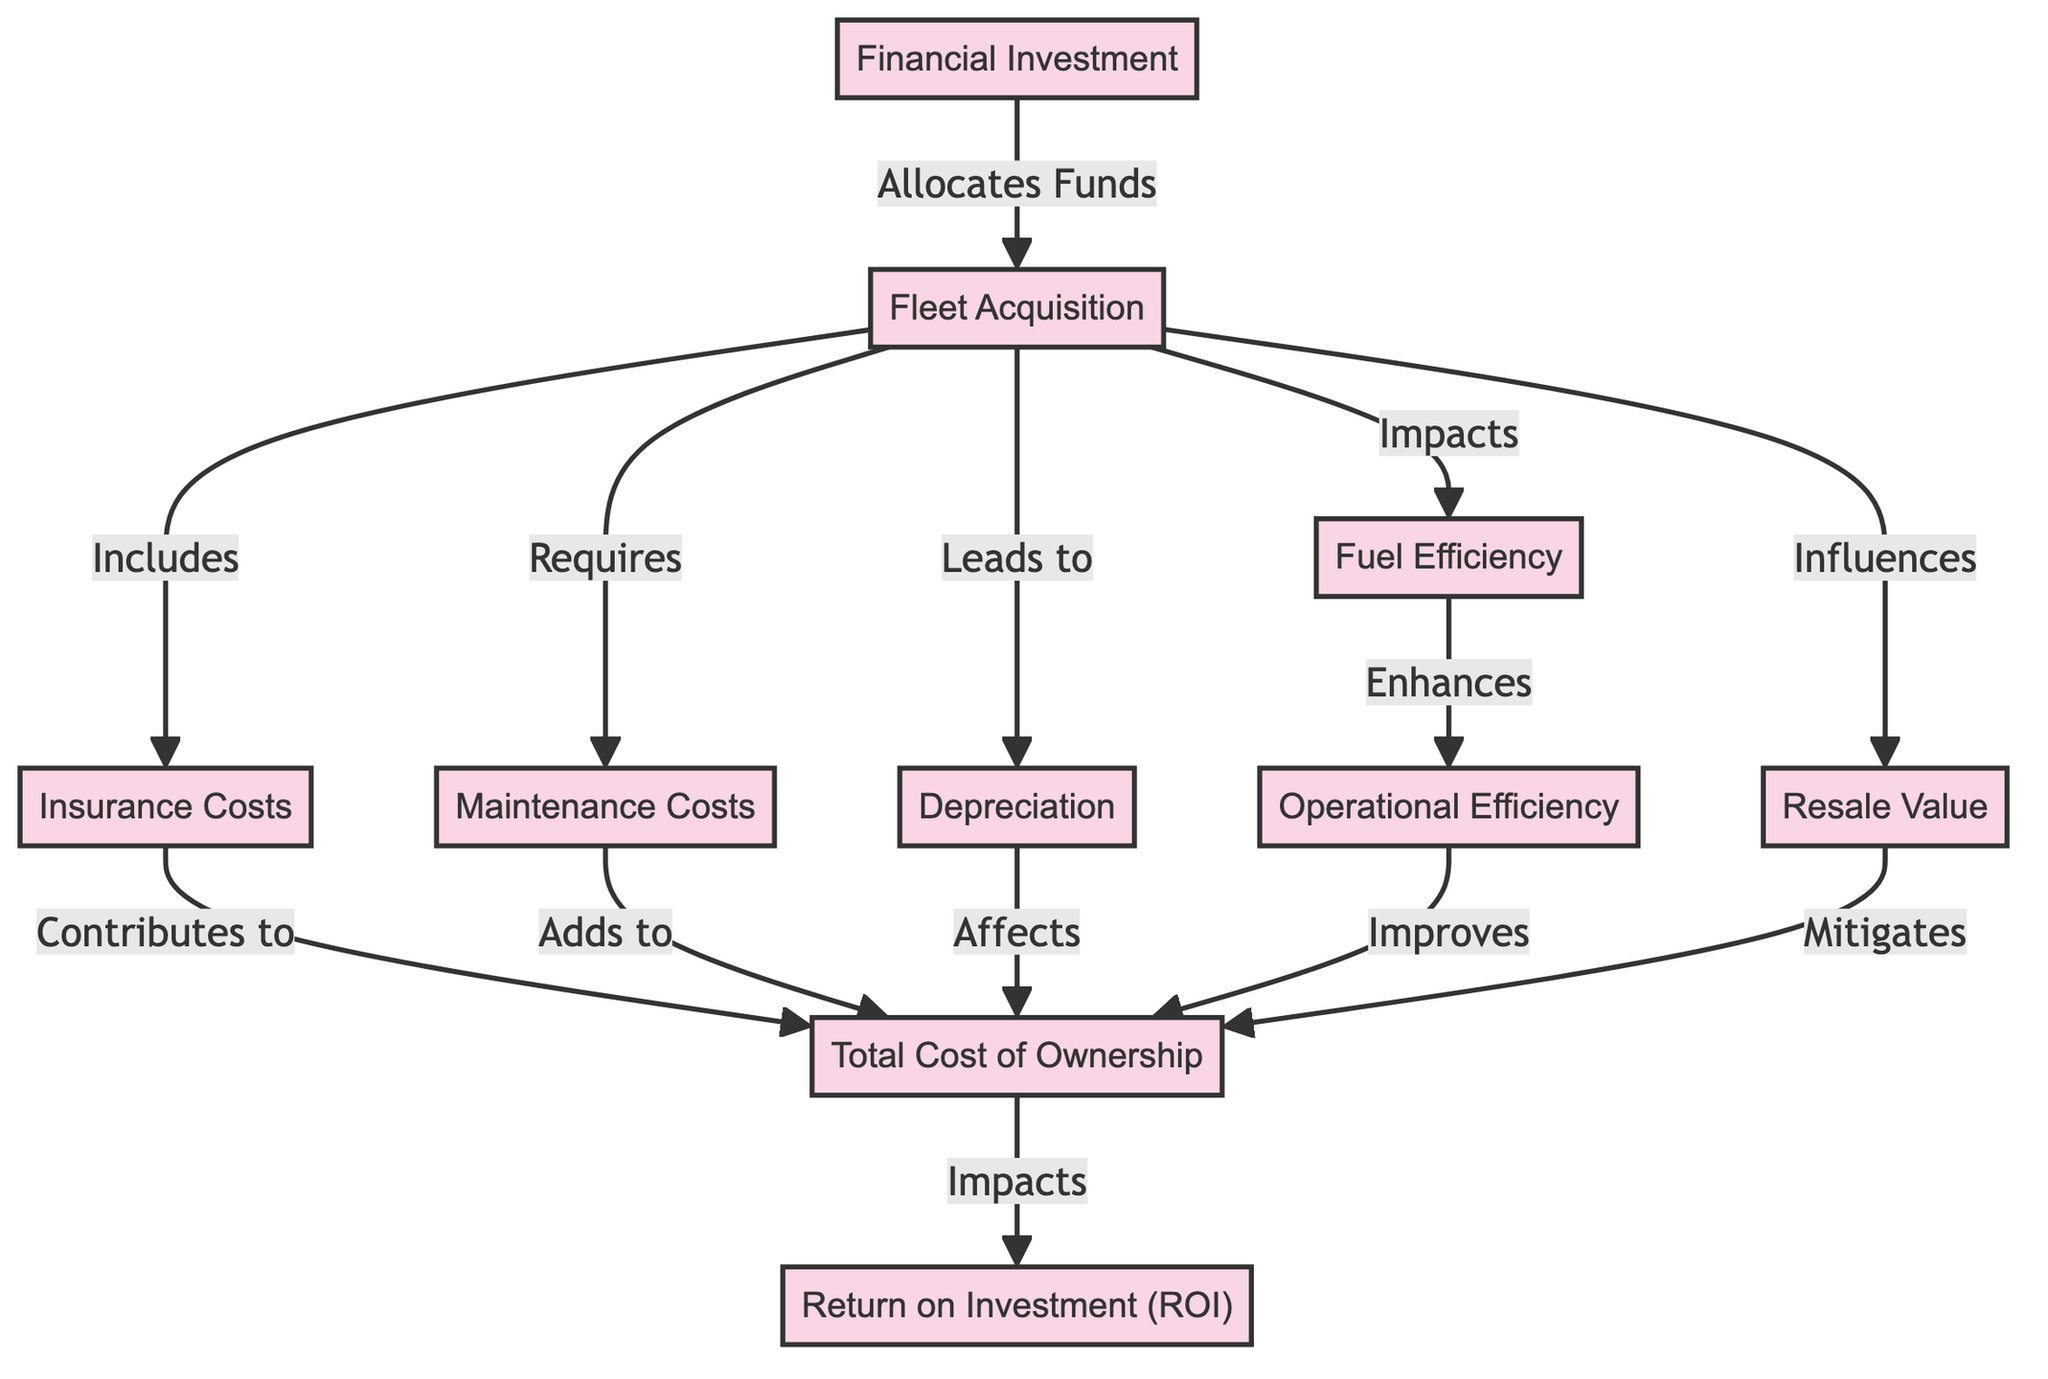What is the first node in the diagram? The first node in the diagram is Financial Investment, which is the starting point of the directed graph representing the flow of financial decision breakdown for fleet management optimization.
Answer: Financial Investment How many nodes are in this directed graph? By counting the entries in the nodes list, we find that there are 10 unique nodes presented in the diagram, each representing a different aspect of financial decision-making for fleet management.
Answer: 10 What is the relationship between Fleet Acquisition and Depreciation? The directed graph indicates that Fleet Acquisition leads to Depreciation, meaning that the process of acquiring a fleet will result in the depreciation value of the vehicles.
Answer: Leads to Which node contributes to Total Cost of Ownership? Based on the graph, Insurance Costs, Maintenance Costs, Depreciation, and Operational Efficiency all contribute to the Total Cost of Ownership, indicating multiple factors affecting this overall cost.
Answer: Insurance Costs Which node has the strongest impact on ROI? The Total Cost of Ownership impacts the Return on Investment (ROI), as ROI is directly influenced by how much it costs to own the fleet compared to the returns it generates.
Answer: Total Cost of Ownership What influences Resale Value? Fleet Acquisition directly influences Resale Value, meaning that decisions made when acquiring a fleet can affect the value of the vehicles when they are sold later.
Answer: Fleet Acquisition What enhances Operational Efficiency? Fuel Efficiency is indicated as enhancing Operational Efficiency, meaning improvements in fuel consumption can lead to better overall performance in fleet operations.
Answer: Fuel Efficiency How many edges are in this directed graph? To determine the number of edges, we count all the relationships between the nodes, which amounts to 12 edges in the graph representing various connections in fleet management financial decisions.
Answer: 12 What does Resale Value do for Total Cost of Ownership? Resale Value mitigates the Total Cost of Ownership, indicating that a higher resale price can reduce the overall expenses incurred in owning the fleet.
Answer: Mitigates 